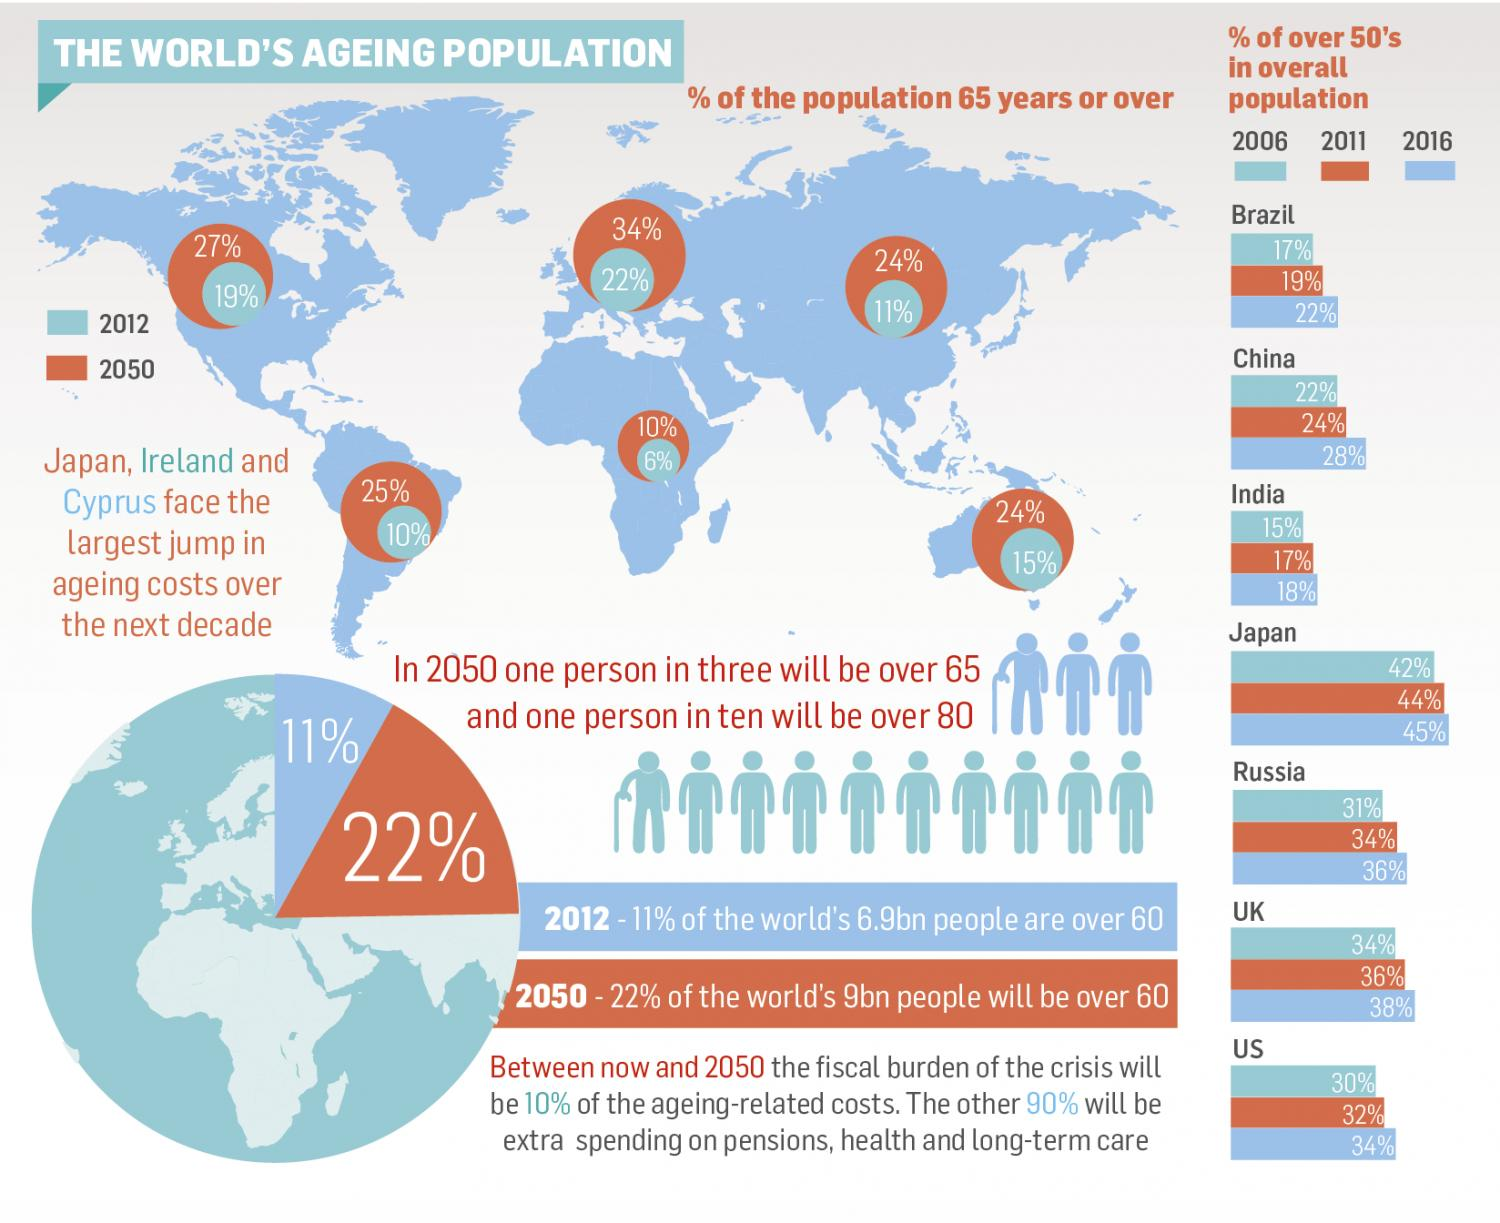Specify some key components in this picture. By 2050, it is projected that there will be a 1:3 ratio of senior citizens to young people in the population. By 2050, the ratio of super senior citizens to the rest of the population is expected to be 1:10, indicating a significant increase in the older population. In 2006, it was estimated that approximately 15% of the citizens in India were above the age of 50. In 2016, approximately 28% of the citizens in China were over the age of 50. In 2011, approximately 36% of citizens in the United Kingdom were above the age of 50. 